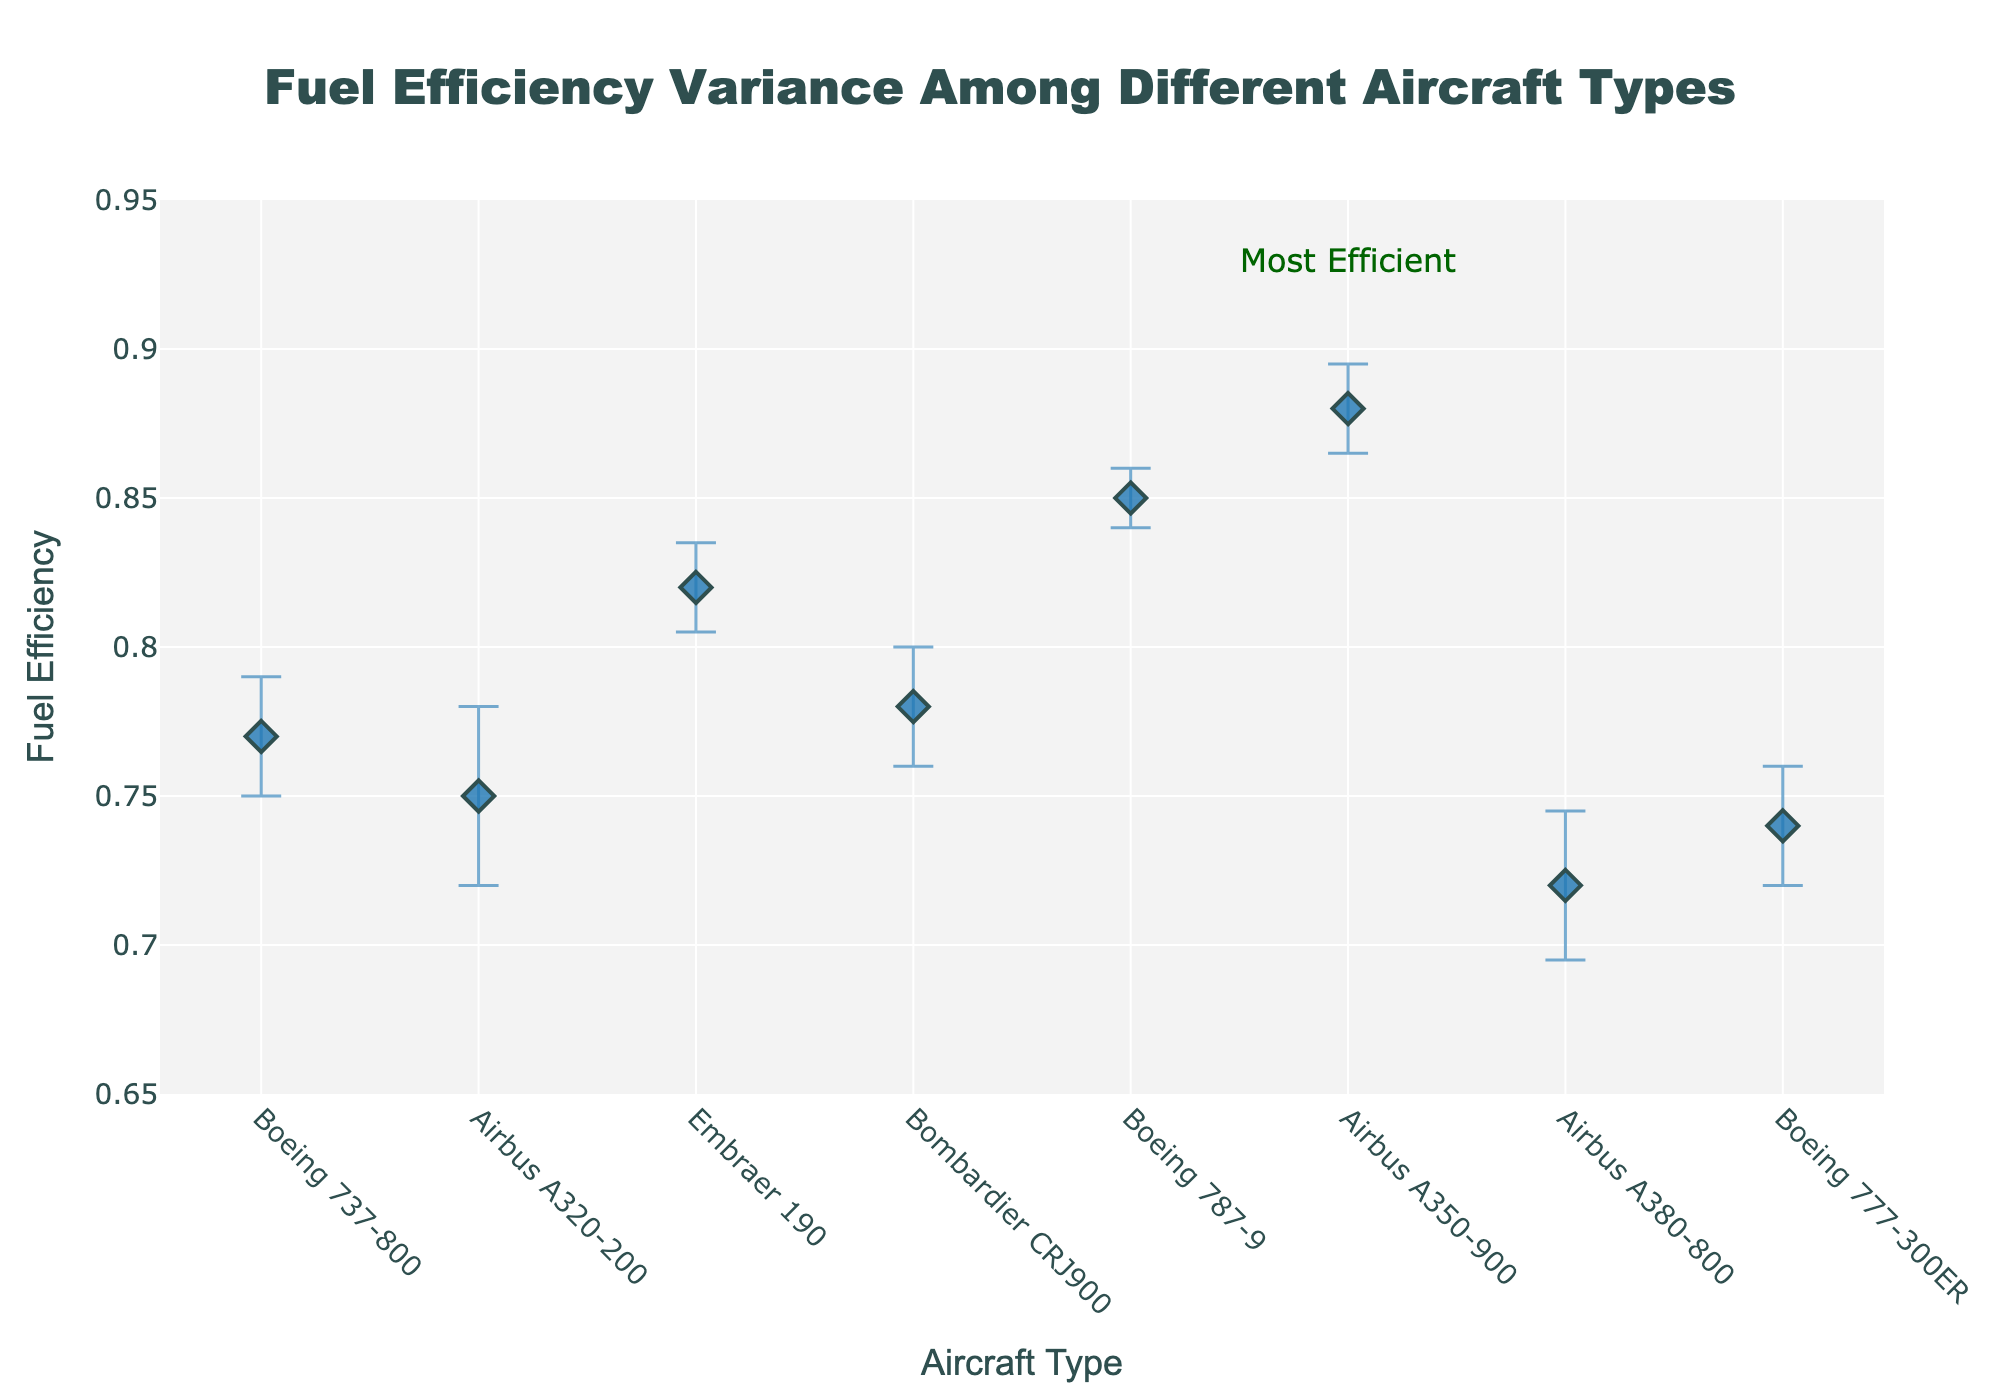What is the title of the plot? The title is always located at the top center of the plot and is often larger and bolder compared to other text. It aims to describe the overall purpose of the visualization. In this case, the title should be clearly visible.
Answer: Fuel Efficiency Variance Among Different Aircraft Types What is the y-axis representing? The y-axis typically has a label indicating what it measures. In this case, you can see the label is "Fuel Efficiency," which tells us that the y-axis represents fuel efficiency values for different aircraft types.
Answer: Fuel Efficiency Which aircraft type has the highest fuel efficiency? By identifying the data point positioned the highest on the y-axis, we can determine which aircraft type has the highest fuel efficiency. Additionally, the most efficient aircraft is highlighted with a rectangle, specifically in Light Green. The annotation "Most Efficient" is also added to this data point for clarification.
Answer: Airbus A350-900 What is the difference in fuel efficiency between Boeing 737-800 and Boeing 787-9? First, locate the fuel efficiency values for Boeing 737-800 and Boeing 787-9. The Boeing 737-800 has a fuel efficiency value of 0.77, while the Boeing 787-9 has a value of 0.85. Then, subtract the former value from the latter: 0.85 - 0.77.
Answer: 0.08 How many aircraft types have a fuel efficiency below 0.80? Identify each data point representing different aircraft types and count those with fuel efficiency values less than 0.80 as shown on the y-axis. The aircraft with fuel efficiencies below 0.80 are the Boeing 737-800, Airbus A320-200, Airbus A380-800, and Boeing 777-300ER.
Answer: Four Which aircraft types have error bars that appear most prominently (largest)? Error bars give visual cues about the uncertainty or variability of the data points. To identify the largest error bars, we observe how tall they are visually. The Airbus A320-200 and Airbus A380-800 have the largest error bars visually compared to other types.
Answer: Airbus A320-200, Airbus A380-800 Does the Embraer 190 have a higher or lower fuel efficiency in comparison to Bombardier CRJ900? Compare the vertical positions of the data points for Embraer 190 and Bombardier CRJ900. Embraer 190 is positioned at 0.82, while Bombardier CRJ900 is at 0.78. Therefore, Embraer 190 has a higher fuel efficiency.
Answer: Higher Which aircraft type has the smallest margin of error for fuel efficiency? The margin of error is depicted by the size of the error bars. Find the aircraft type with the smallest error bar. The Boeing 787-9 has very short error bars, indicating it has the smallest margin of error.
Answer: Boeing 787-9 What is the average fuel efficiency of all aircraft types in the plot? Sum the fuel efficiency values for all displayed aircraft types (0.77, 0.75, 0.82, 0.78, 0.85, 0.88, 0.72, and 0.74) and divide by the number of aircraft types (8). The sum is 6.31, and dividing this by 8 gives 0.78875.
Answer: 0.78875 